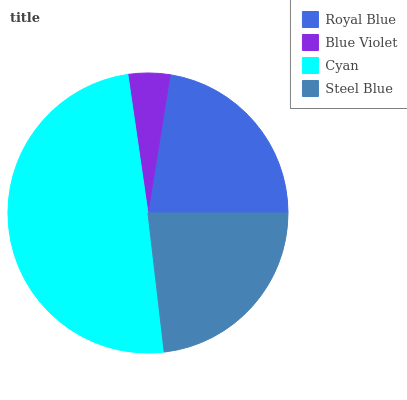Is Blue Violet the minimum?
Answer yes or no. Yes. Is Cyan the maximum?
Answer yes or no. Yes. Is Cyan the minimum?
Answer yes or no. No. Is Blue Violet the maximum?
Answer yes or no. No. Is Cyan greater than Blue Violet?
Answer yes or no. Yes. Is Blue Violet less than Cyan?
Answer yes or no. Yes. Is Blue Violet greater than Cyan?
Answer yes or no. No. Is Cyan less than Blue Violet?
Answer yes or no. No. Is Steel Blue the high median?
Answer yes or no. Yes. Is Royal Blue the low median?
Answer yes or no. Yes. Is Royal Blue the high median?
Answer yes or no. No. Is Steel Blue the low median?
Answer yes or no. No. 